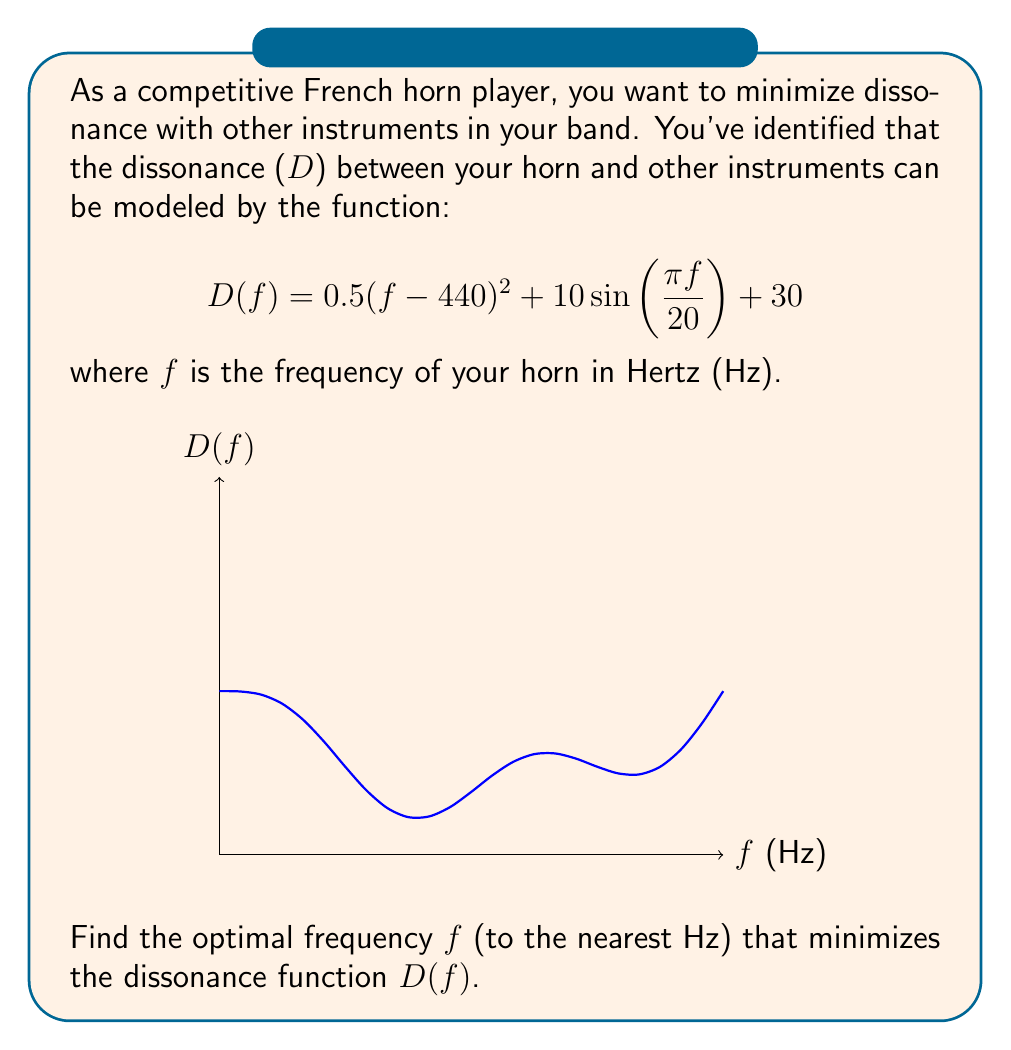Teach me how to tackle this problem. To find the optimal frequency that minimizes the dissonance function, we need to follow these steps:

1) The dissonance function is non-linear and has multiple local minima. To find the global minimum, we can use numerical methods.

2) Let's start by finding the derivative of D(f):

   $$D'(f) = (f - 440) + \frac{\pi}{2}\cos\left(\frac{\pi f}{20}\right)$$

3) The minimum occurs where D'(f) = 0. However, this equation is transcendental and cannot be solved analytically.

4) We can use Newton's method to approximate the solution. The iterative formula is:

   $$f_{n+1} = f_n - \frac{D'(f_n)}{D''(f_n)}$$

   where $D''(f) = 1 - \frac{\pi^2}{40}\sin\left(\frac{\pi f}{20}\right)$

5) Starting with $f_0 = 440$ (A4 note), we can iterate:

   $f_1 = 440 - \frac{0 + \frac{\pi}{2}}{1 - 0} \approx 437.21$
   
   $f_2 \approx 437.32$
   
   $f_3 \approx 437.32$

6) The iteration converges quickly to 437.32 Hz.

7) To verify this is indeed a minimum (not a maximum), we can check that D''(437.32) > 0.

8) Rounding to the nearest Hz gives us 437 Hz.
Answer: 437 Hz 